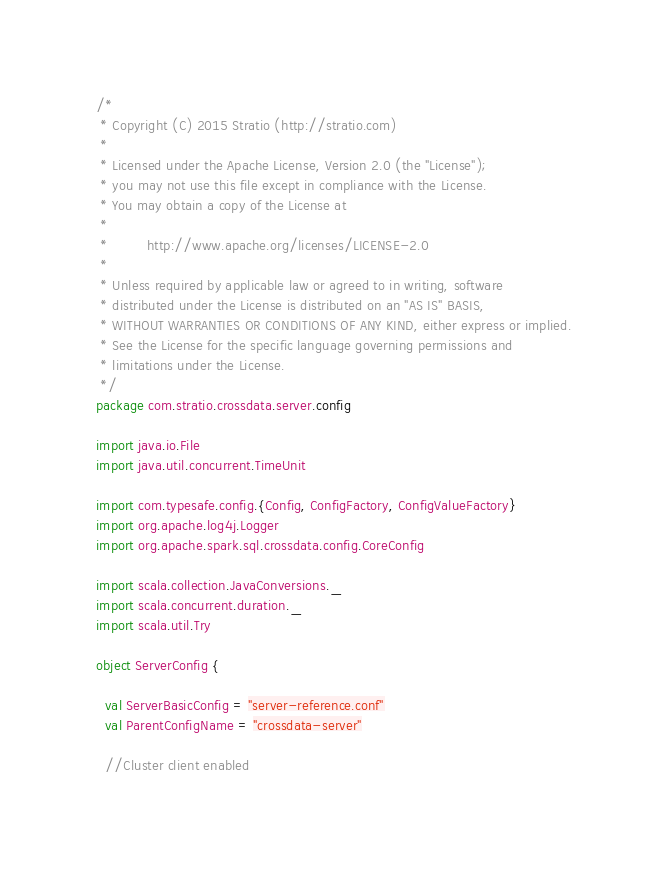Convert code to text. <code><loc_0><loc_0><loc_500><loc_500><_Scala_>/*
 * Copyright (C) 2015 Stratio (http://stratio.com)
 *
 * Licensed under the Apache License, Version 2.0 (the "License");
 * you may not use this file except in compliance with the License.
 * You may obtain a copy of the License at
 *
 *         http://www.apache.org/licenses/LICENSE-2.0
 *
 * Unless required by applicable law or agreed to in writing, software
 * distributed under the License is distributed on an "AS IS" BASIS,
 * WITHOUT WARRANTIES OR CONDITIONS OF ANY KIND, either express or implied.
 * See the License for the specific language governing permissions and
 * limitations under the License.
 */
package com.stratio.crossdata.server.config

import java.io.File
import java.util.concurrent.TimeUnit

import com.typesafe.config.{Config, ConfigFactory, ConfigValueFactory}
import org.apache.log4j.Logger
import org.apache.spark.sql.crossdata.config.CoreConfig

import scala.collection.JavaConversions._
import scala.concurrent.duration._
import scala.util.Try

object ServerConfig {

  val ServerBasicConfig = "server-reference.conf"
  val ParentConfigName = "crossdata-server"

  //Cluster client enabled</code> 